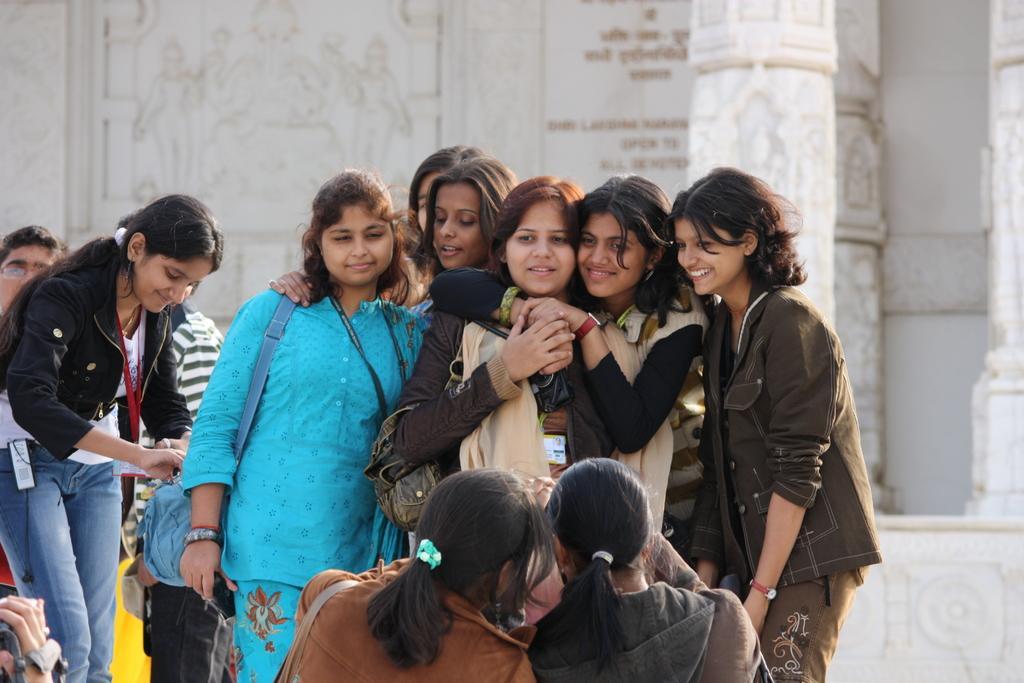How would you summarize this image in a sentence or two? In this image we can see many girls. Few are holding bags. In the back there is a wall. Also there is a pillar. On the wall something is written. Also there is a drawing on the wall. 